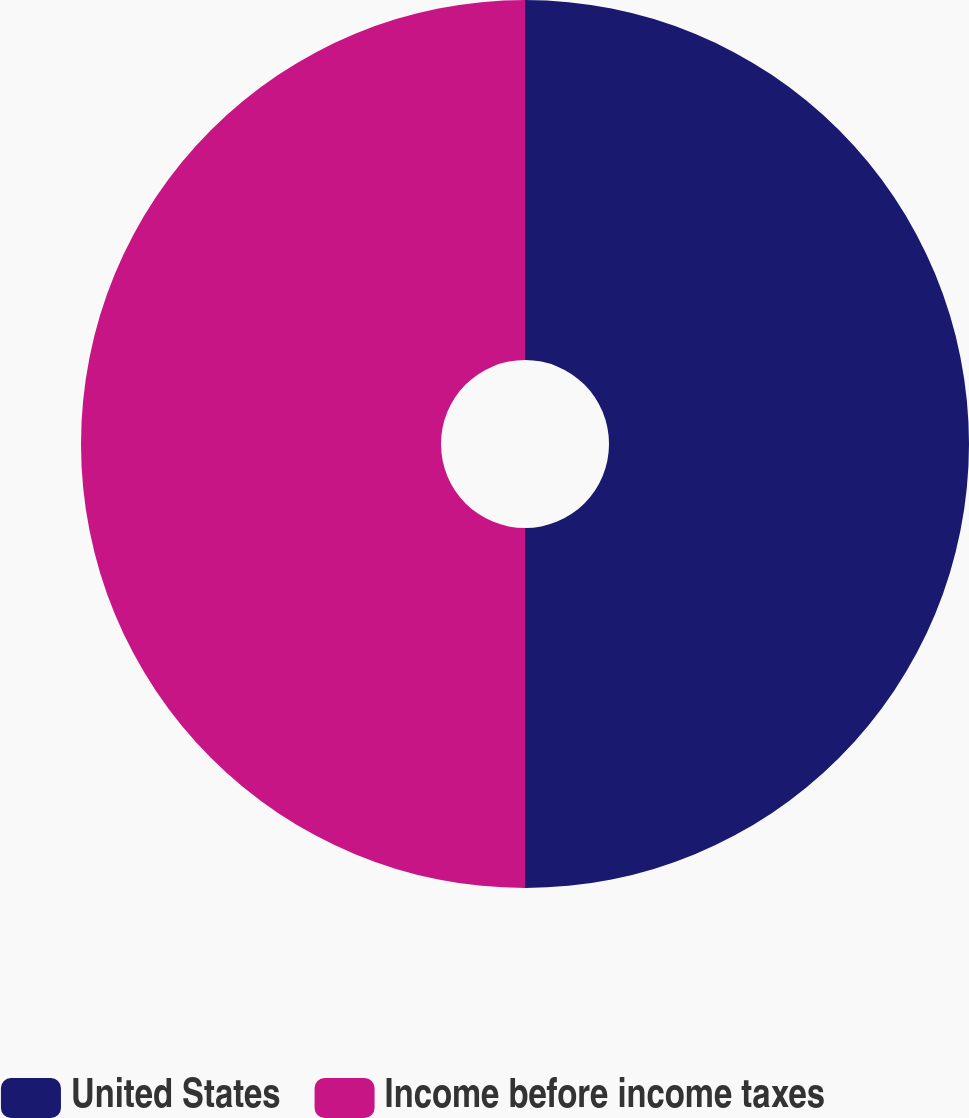Convert chart to OTSL. <chart><loc_0><loc_0><loc_500><loc_500><pie_chart><fcel>United States<fcel>Income before income taxes<nl><fcel>50.0%<fcel>50.0%<nl></chart> 